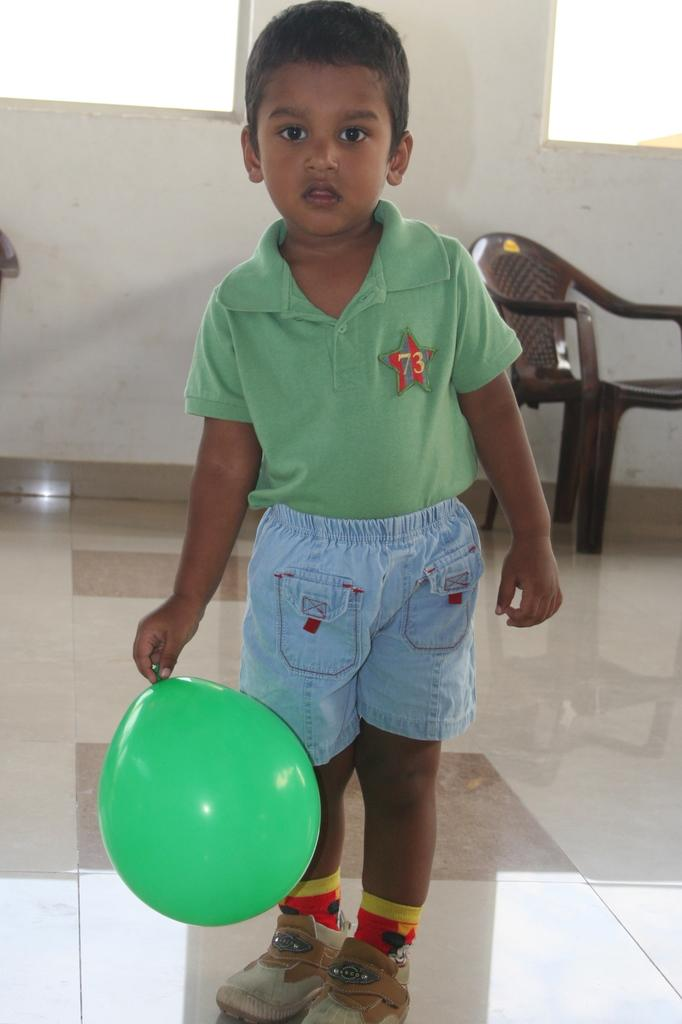Who is the main subject in the image? There is a boy in the image. What is the boy doing in the image? The boy is standing in the image. What object is the boy holding in the image? The boy is holding a green balloon in the image. What can be seen in the background of the image? There is a chair in the background of the image. What type of steam can be seen coming from the boy's ears in the image? There is no steam coming from the boy's ears in the image; it is not present. 